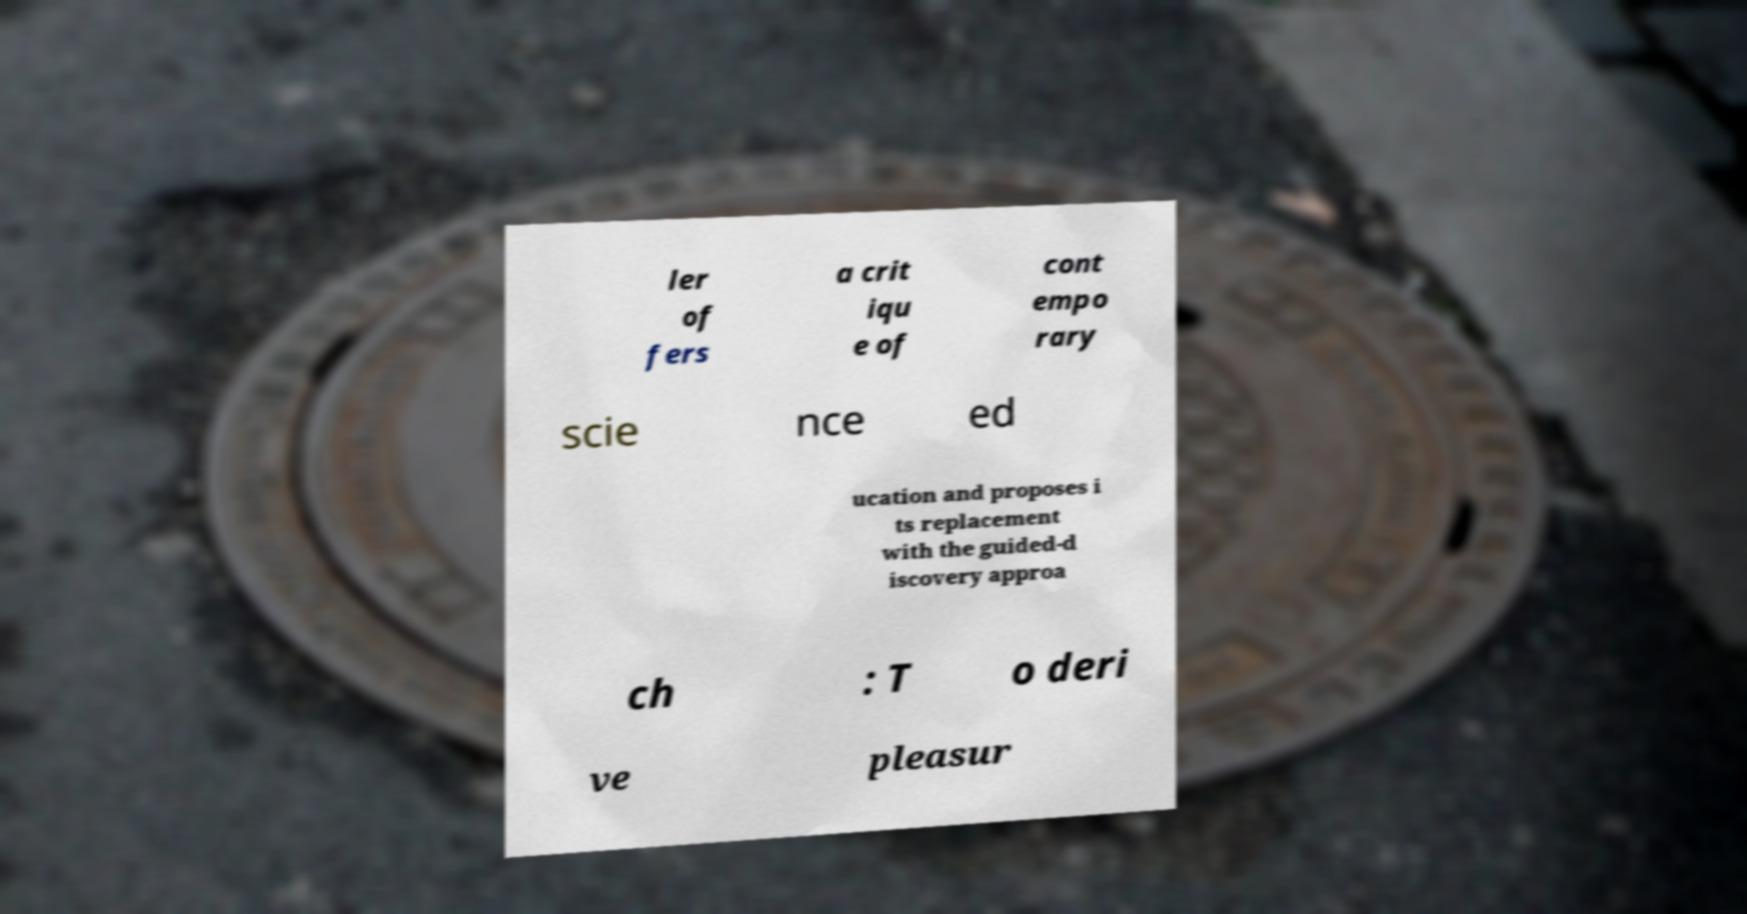There's text embedded in this image that I need extracted. Can you transcribe it verbatim? ler of fers a crit iqu e of cont empo rary scie nce ed ucation and proposes i ts replacement with the guided-d iscovery approa ch : T o deri ve pleasur 